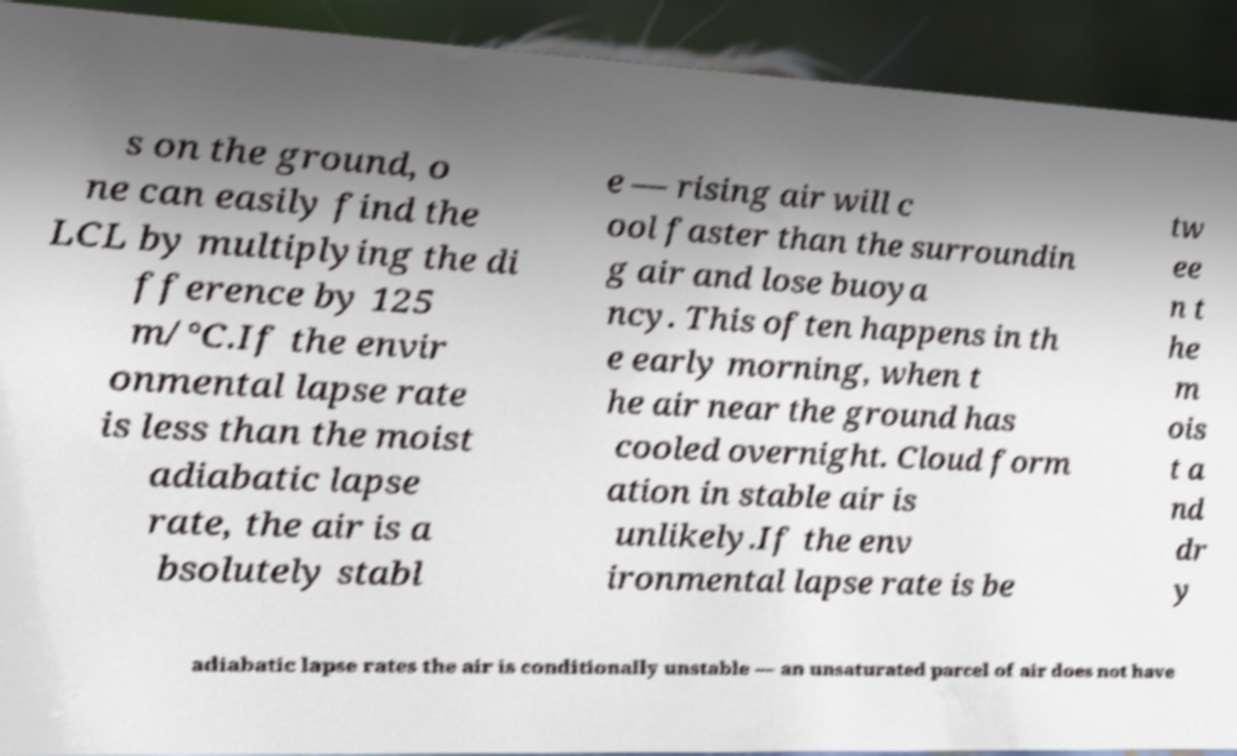Please read and relay the text visible in this image. What does it say? s on the ground, o ne can easily find the LCL by multiplying the di fference by 125 m/°C.If the envir onmental lapse rate is less than the moist adiabatic lapse rate, the air is a bsolutely stabl e — rising air will c ool faster than the surroundin g air and lose buoya ncy. This often happens in th e early morning, when t he air near the ground has cooled overnight. Cloud form ation in stable air is unlikely.If the env ironmental lapse rate is be tw ee n t he m ois t a nd dr y adiabatic lapse rates the air is conditionally unstable — an unsaturated parcel of air does not have 